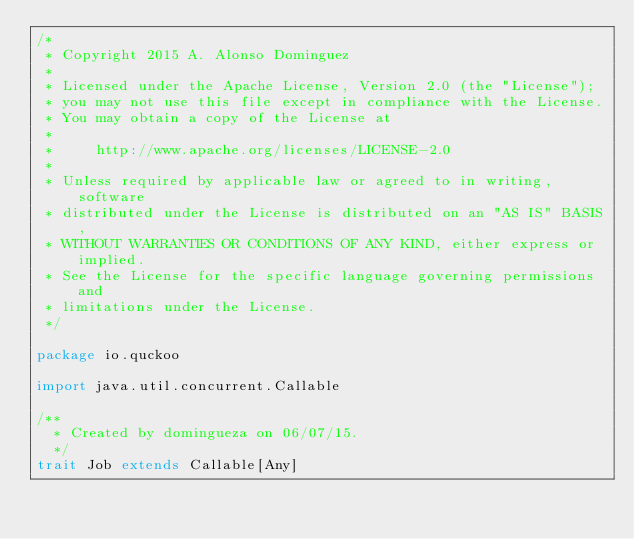Convert code to text. <code><loc_0><loc_0><loc_500><loc_500><_Scala_>/*
 * Copyright 2015 A. Alonso Dominguez
 *
 * Licensed under the Apache License, Version 2.0 (the "License");
 * you may not use this file except in compliance with the License.
 * You may obtain a copy of the License at
 *
 *     http://www.apache.org/licenses/LICENSE-2.0
 *
 * Unless required by applicable law or agreed to in writing, software
 * distributed under the License is distributed on an "AS IS" BASIS,
 * WITHOUT WARRANTIES OR CONDITIONS OF ANY KIND, either express or implied.
 * See the License for the specific language governing permissions and
 * limitations under the License.
 */

package io.quckoo

import java.util.concurrent.Callable

/**
  * Created by domingueza on 06/07/15.
  */
trait Job extends Callable[Any]
</code> 